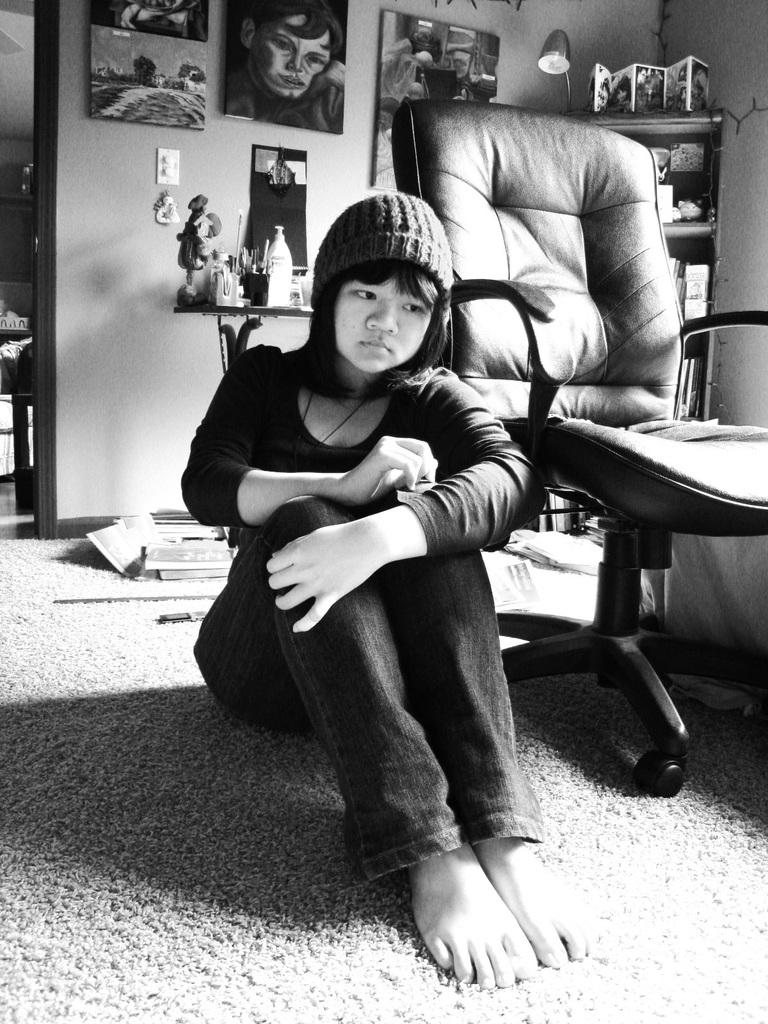What is the person in the image doing? The person is sitting on the floor in the image. What is located to the right of the person? There is a chair to the right of the person. What can be seen on the wall in the background of the image? There are frames attached to the wall in the background of the image. What type of pot is being used to comb the person's hair in the image? There is no pot or combing activity present in the image. 